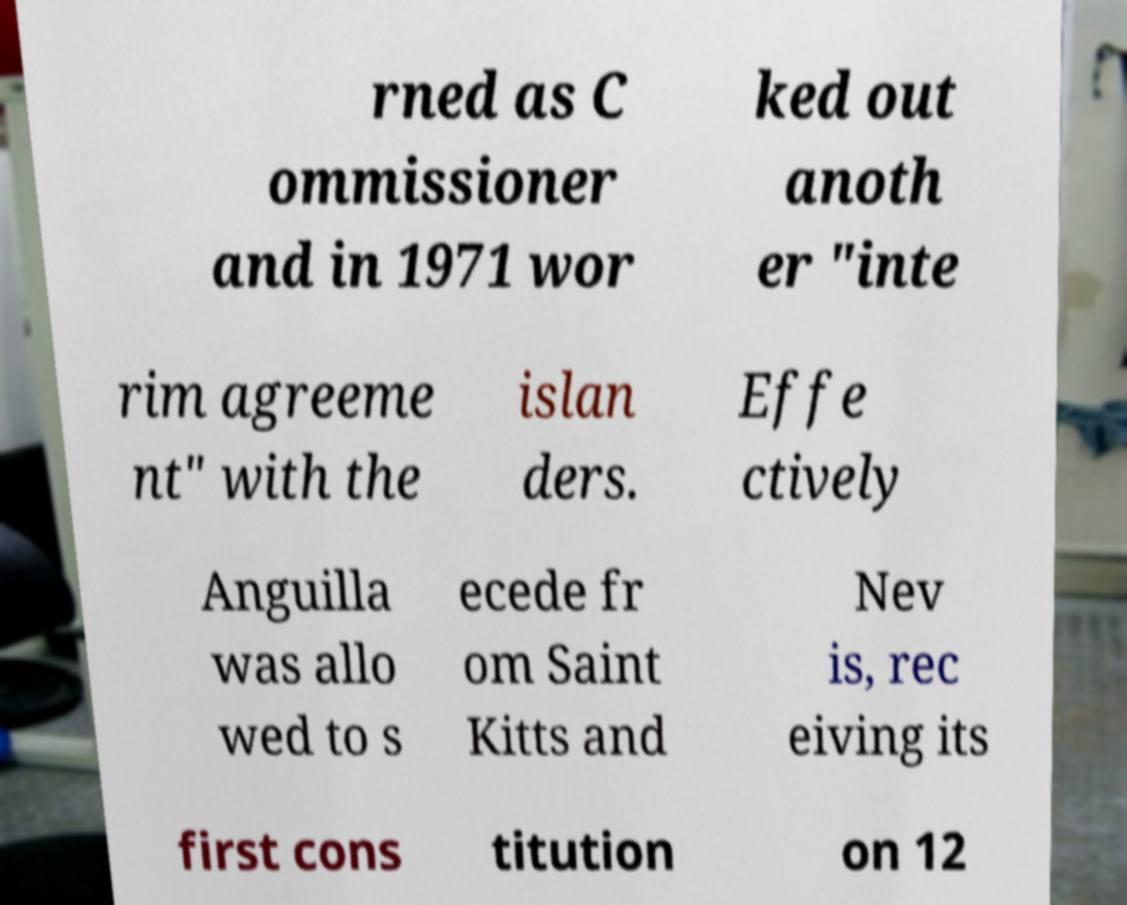Can you accurately transcribe the text from the provided image for me? rned as C ommissioner and in 1971 wor ked out anoth er "inte rim agreeme nt" with the islan ders. Effe ctively Anguilla was allo wed to s ecede fr om Saint Kitts and Nev is, rec eiving its first cons titution on 12 